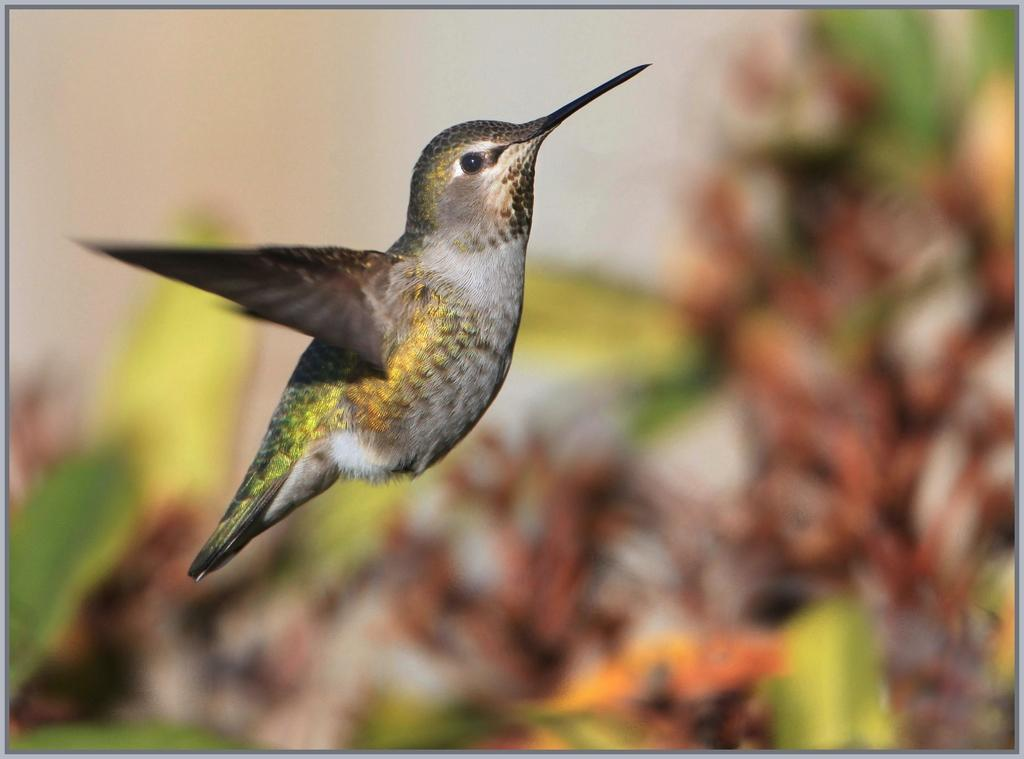What type of bird is in the image? There is a humming bird in the image. What is the humming bird doing in the image? The humming bird is flying in the image. Can you describe the background of the image? The background of the image appears blurred. What type of sail can be seen on the ocean in the image? There is no sail or ocean present in the image; it features a humming bird flying with a blurred background. 